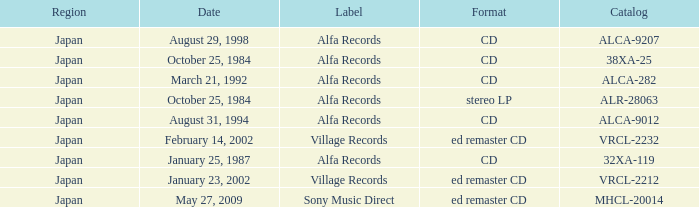What was the region of the release from May 27, 2009? Japan. 